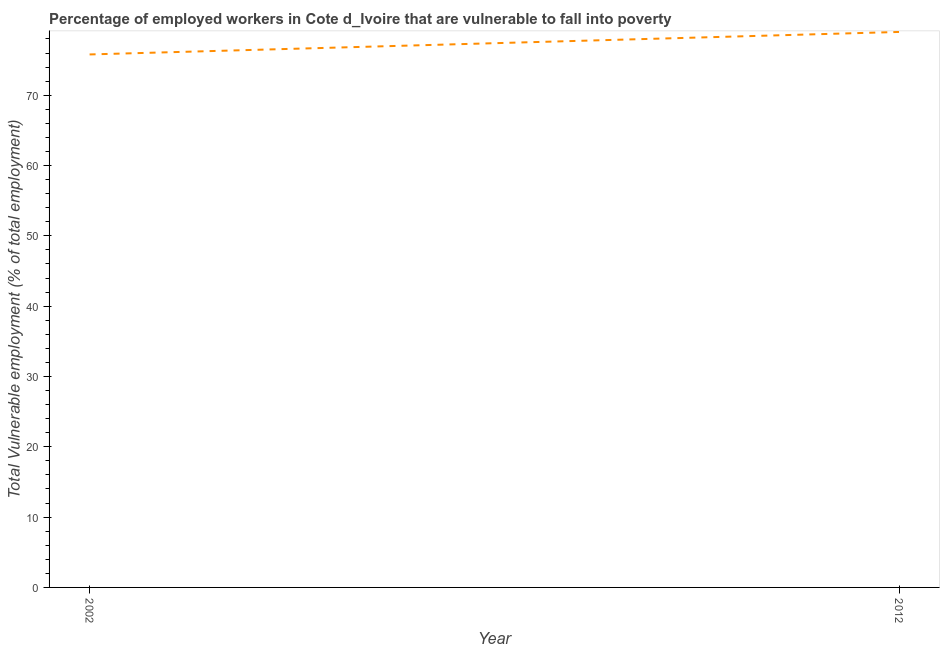What is the total vulnerable employment in 2012?
Offer a very short reply. 79. Across all years, what is the maximum total vulnerable employment?
Provide a succinct answer. 79. Across all years, what is the minimum total vulnerable employment?
Offer a very short reply. 75.8. In which year was the total vulnerable employment maximum?
Ensure brevity in your answer.  2012. What is the sum of the total vulnerable employment?
Your answer should be compact. 154.8. What is the difference between the total vulnerable employment in 2002 and 2012?
Make the answer very short. -3.2. What is the average total vulnerable employment per year?
Keep it short and to the point. 77.4. What is the median total vulnerable employment?
Make the answer very short. 77.4. In how many years, is the total vulnerable employment greater than 68 %?
Keep it short and to the point. 2. Do a majority of the years between 2012 and 2002 (inclusive) have total vulnerable employment greater than 48 %?
Give a very brief answer. No. What is the ratio of the total vulnerable employment in 2002 to that in 2012?
Make the answer very short. 0.96. How many lines are there?
Your response must be concise. 1. What is the difference between two consecutive major ticks on the Y-axis?
Your response must be concise. 10. Are the values on the major ticks of Y-axis written in scientific E-notation?
Make the answer very short. No. Does the graph contain grids?
Your response must be concise. No. What is the title of the graph?
Make the answer very short. Percentage of employed workers in Cote d_Ivoire that are vulnerable to fall into poverty. What is the label or title of the Y-axis?
Provide a short and direct response. Total Vulnerable employment (% of total employment). What is the Total Vulnerable employment (% of total employment) in 2002?
Your answer should be very brief. 75.8. What is the Total Vulnerable employment (% of total employment) in 2012?
Provide a short and direct response. 79. What is the ratio of the Total Vulnerable employment (% of total employment) in 2002 to that in 2012?
Keep it short and to the point. 0.96. 